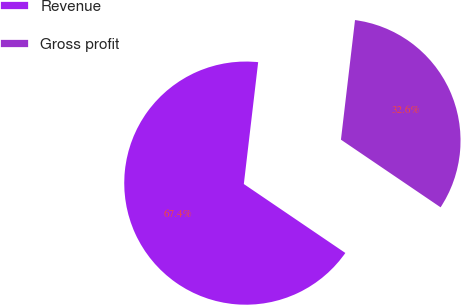Convert chart to OTSL. <chart><loc_0><loc_0><loc_500><loc_500><pie_chart><fcel>Revenue<fcel>Gross profit<nl><fcel>67.37%<fcel>32.63%<nl></chart> 